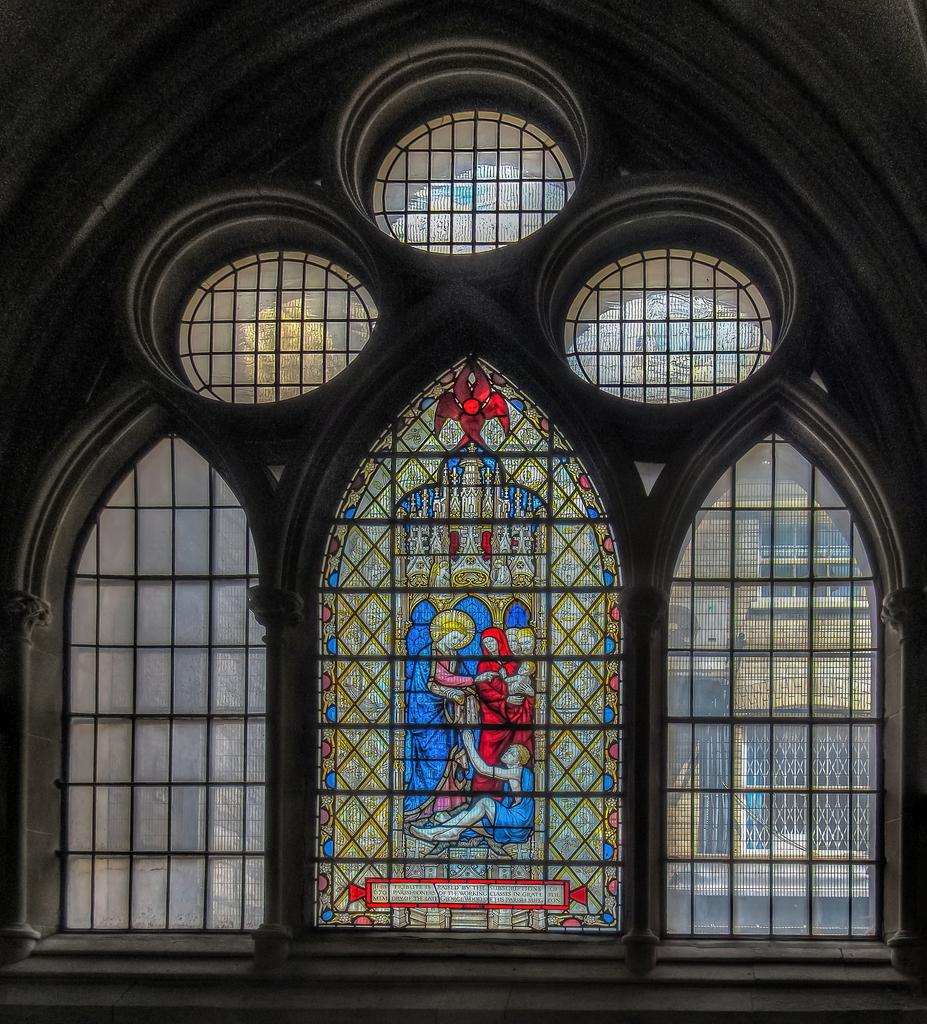What is the prominent feature at the front of the image? There is a stained glass in the front of the image. What can be seen through the prominent feature? There are windows in the image, and a building is visible behind them. What type of unit is present in the image? There is an outdoor unit in the image. What type of juice is being served by the fairies in the image? There are no fairies or juice present in the image. 